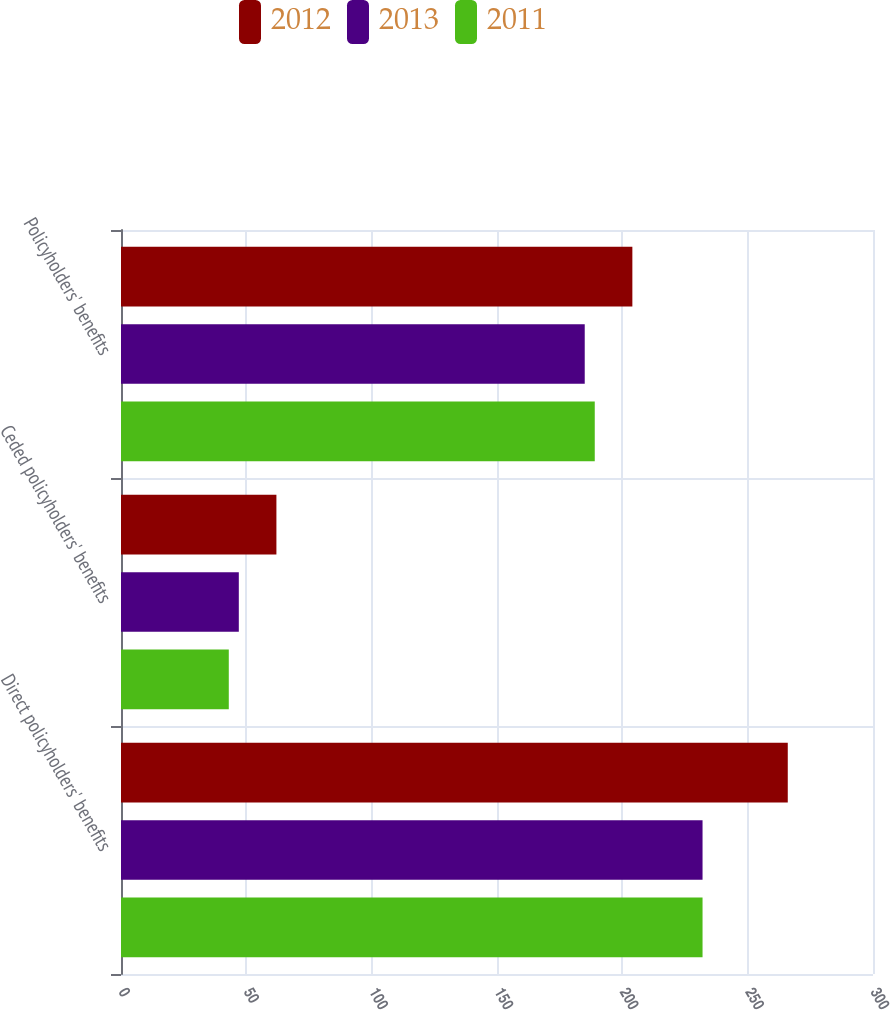Convert chart to OTSL. <chart><loc_0><loc_0><loc_500><loc_500><stacked_bar_chart><ecel><fcel>Direct policyholders' benefits<fcel>Ceded policyholders' benefits<fcel>Policyholders' benefits<nl><fcel>2012<fcel>266<fcel>62<fcel>204<nl><fcel>2013<fcel>232<fcel>47<fcel>185<nl><fcel>2011<fcel>232<fcel>43<fcel>189<nl></chart> 